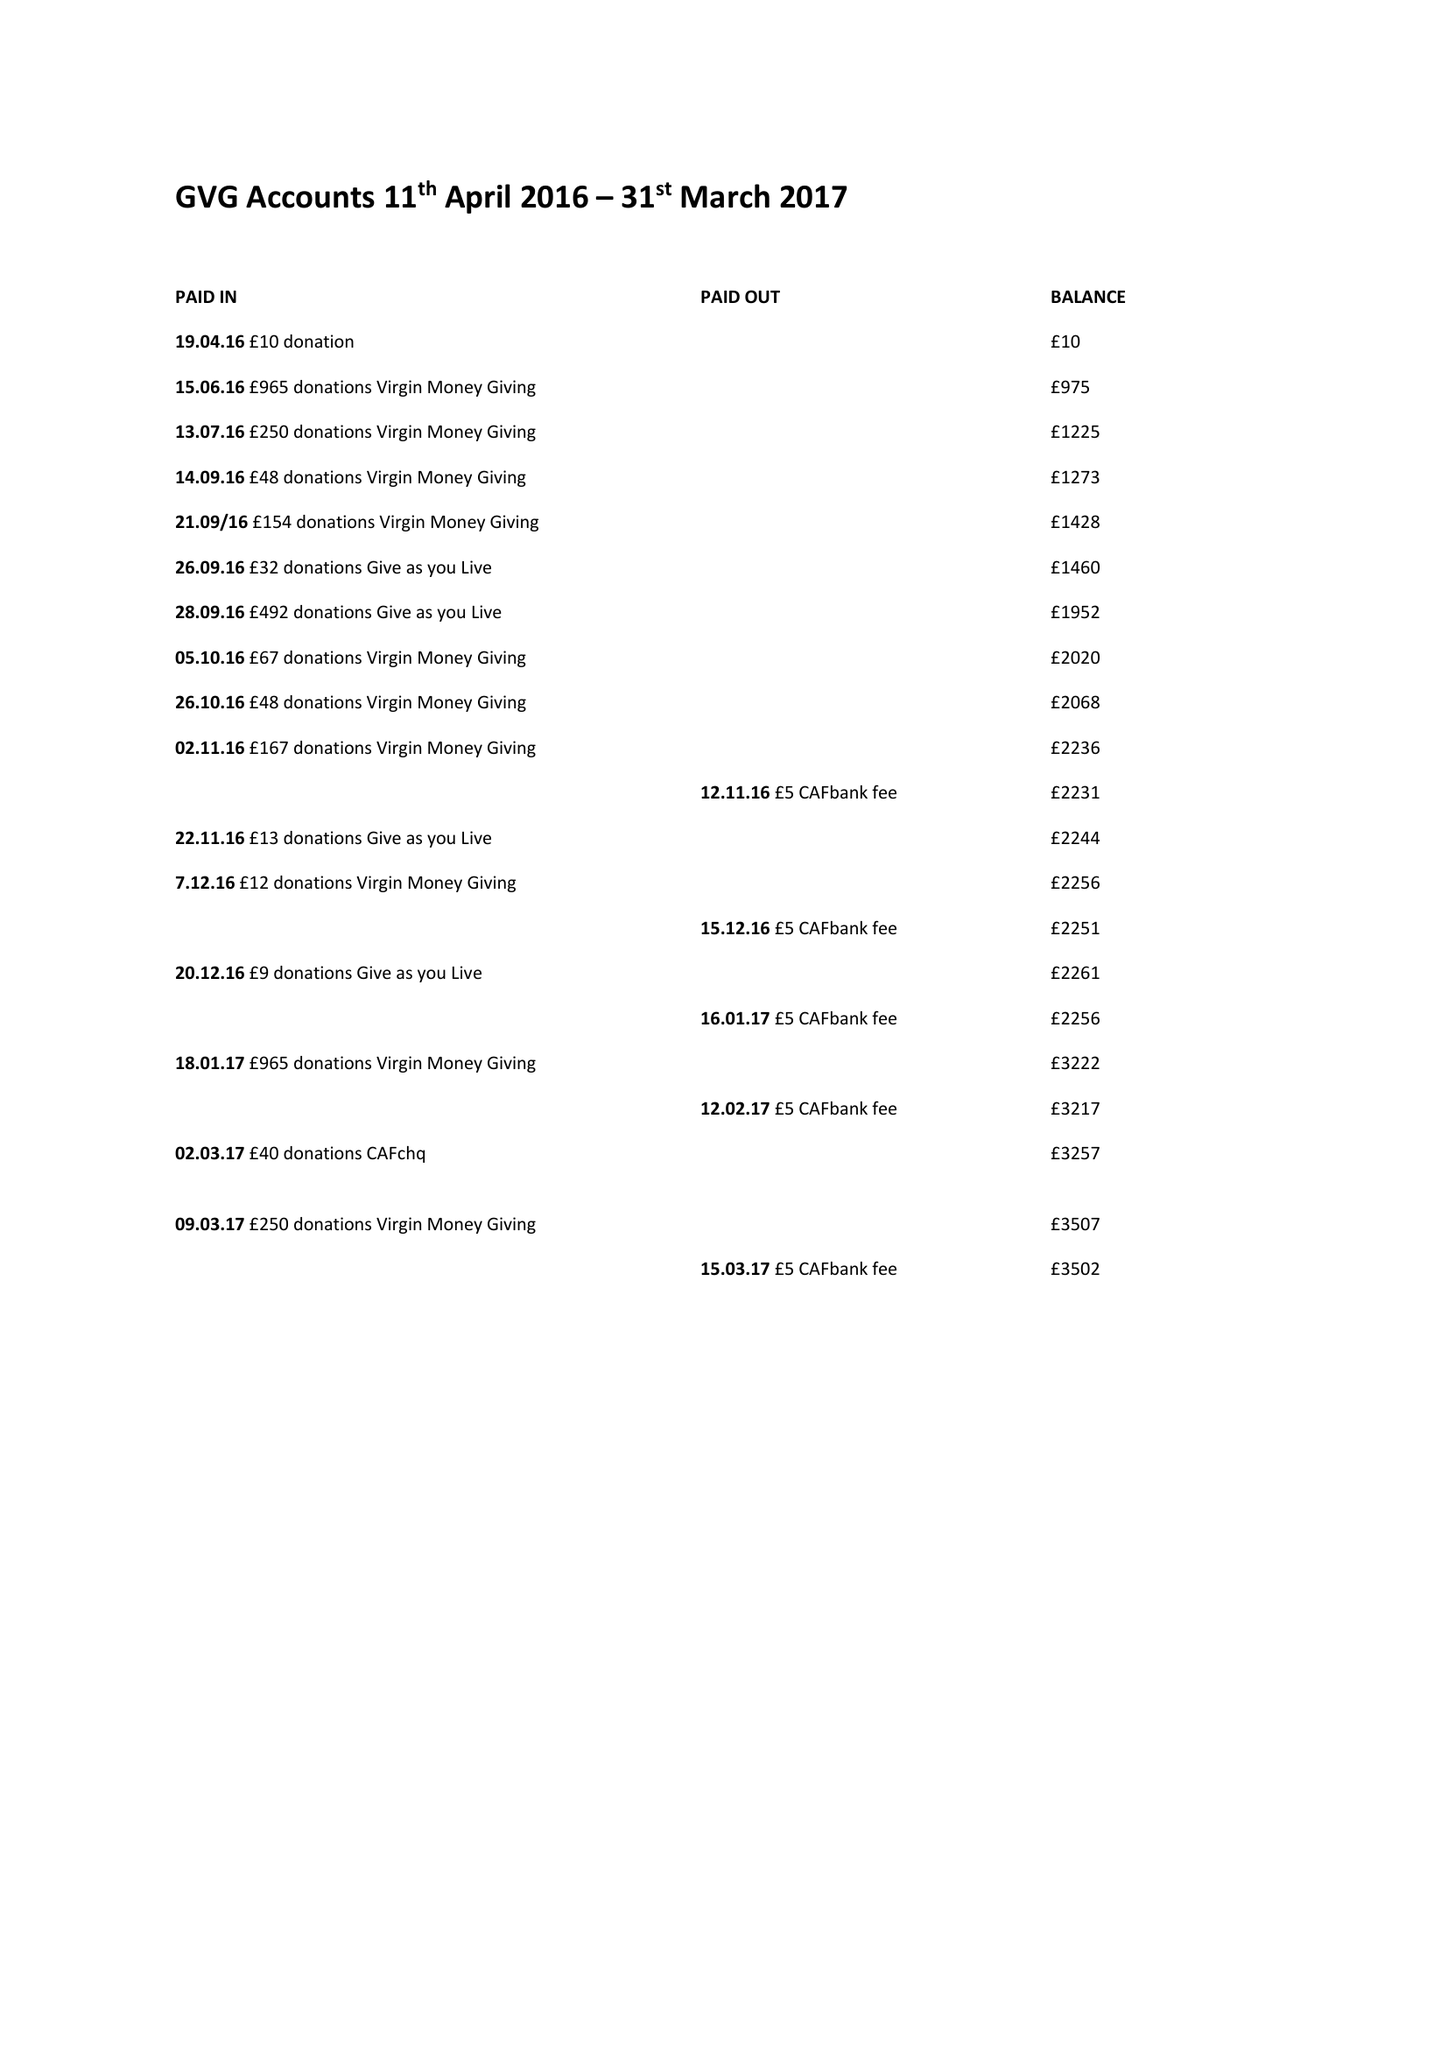What is the value for the address__street_line?
Answer the question using a single word or phrase. 26 BROCKLEBANK ROAD 